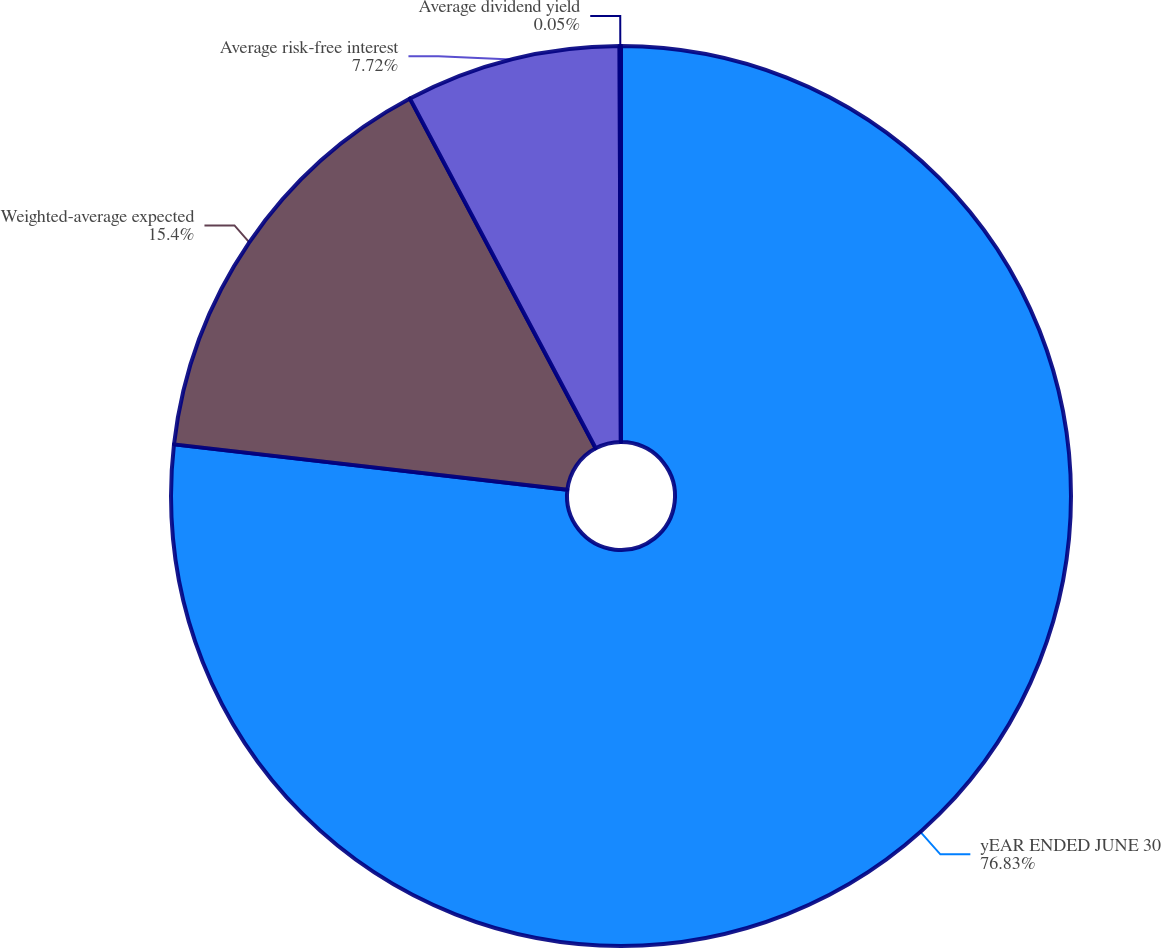Convert chart. <chart><loc_0><loc_0><loc_500><loc_500><pie_chart><fcel>yEAR ENDED JUNE 30<fcel>Weighted-average expected<fcel>Average risk-free interest<fcel>Average dividend yield<nl><fcel>76.83%<fcel>15.4%<fcel>7.72%<fcel>0.05%<nl></chart> 